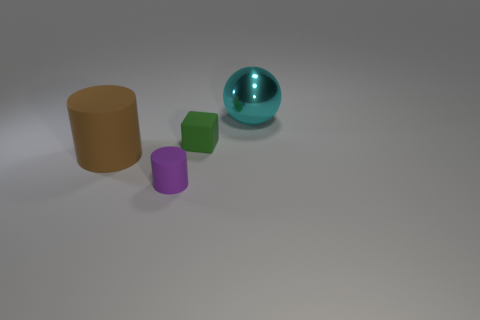Add 4 tiny red rubber cylinders. How many objects exist? 8 Subtract all balls. How many objects are left? 3 Subtract all big brown things. Subtract all large objects. How many objects are left? 1 Add 4 brown matte things. How many brown matte things are left? 5 Add 3 large metallic things. How many large metallic things exist? 4 Subtract 0 gray cylinders. How many objects are left? 4 